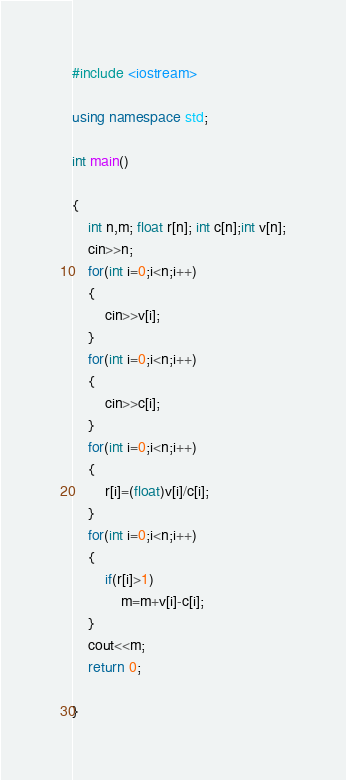Convert code to text. <code><loc_0><loc_0><loc_500><loc_500><_C++_>#include <iostream>

using namespace std;

int main()

{
    int n,m; float r[n]; int c[n];int v[n];
    cin>>n;
    for(int i=0;i<n;i++)
    {
        cin>>v[i];
    }
    for(int i=0;i<n;i++)
    {
        cin>>c[i];
    }
    for(int i=0;i<n;i++)
    {
        r[i]=(float)v[i]/c[i];
    }
    for(int i=0;i<n;i++)
    {
        if(r[i]>1)
            m=m+v[i]-c[i];
    }
    cout<<m;
    return 0;

}
</code> 